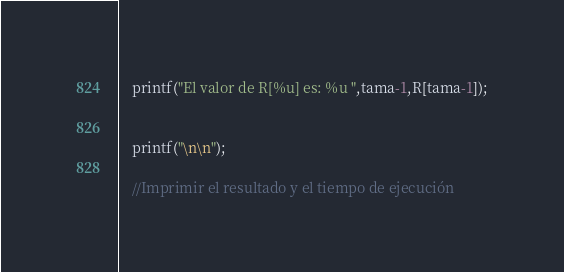Convert code to text. <code><loc_0><loc_0><loc_500><loc_500><_C_>
	printf("El valor de R[%u] es: %u ",tama-1,R[tama-1]);
	
	
	printf("\n\n");

	//Imprimir el resultado y el tiempo de ejecución</code> 